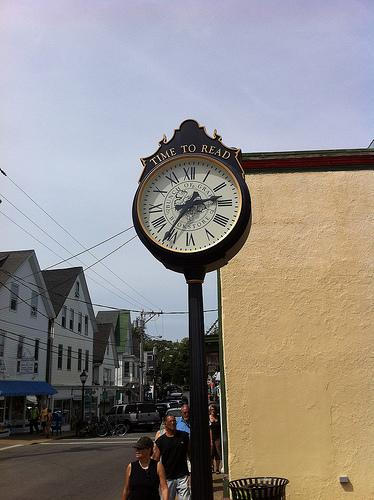Question: what is this photo of?
Choices:
A. A clock.
B. A microwave.
C. An oven.
D. A refrigerator.
Answer with the letter. Answer: A Question: what does the clock say?
Choices:
A. Time for bed.
B. Time for lunch.
C. Time to read.
D. Time to play.
Answer with the letter. Answer: C Question: how many people can you see?
Choices:
A. 7.
B. 4.
C. 8.
D. 9.
Answer with the letter. Answer: B Question: how many clocks are there?
Choices:
A. 7.
B. 8.
C. 9.
D. 1.
Answer with the letter. Answer: D Question: what does the clock sit on?
Choices:
A. A mantle.
B. A post.
C. A table.
D. A bookcase.
Answer with the letter. Answer: B 